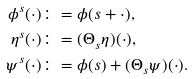Convert formula to latex. <formula><loc_0><loc_0><loc_500><loc_500>\phi ^ { s } ( \cdot ) & \colon = \phi ( s + \cdot ) , \\ \eta ^ { s } ( \cdot ) & \colon = ( \Theta _ { s } \eta ) ( \cdot ) , \\ \psi ^ { s } ( \cdot ) & \colon = \phi ( s ) + ( \Theta _ { s } \psi ) ( \cdot ) .</formula> 